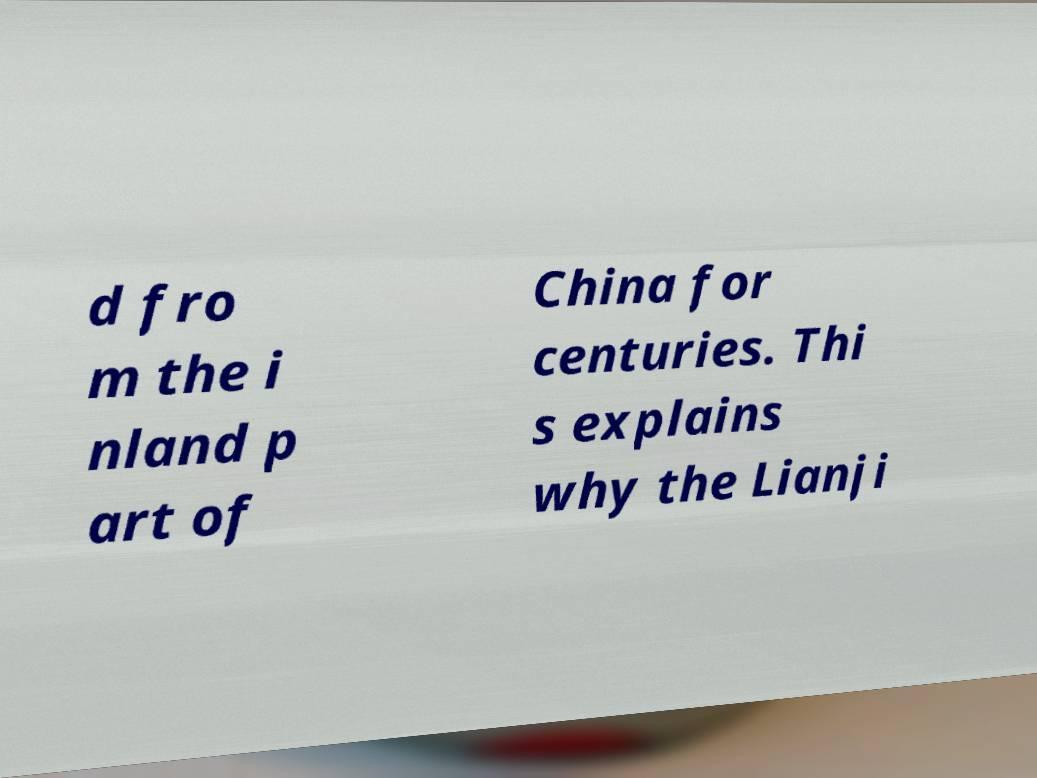Could you extract and type out the text from this image? d fro m the i nland p art of China for centuries. Thi s explains why the Lianji 